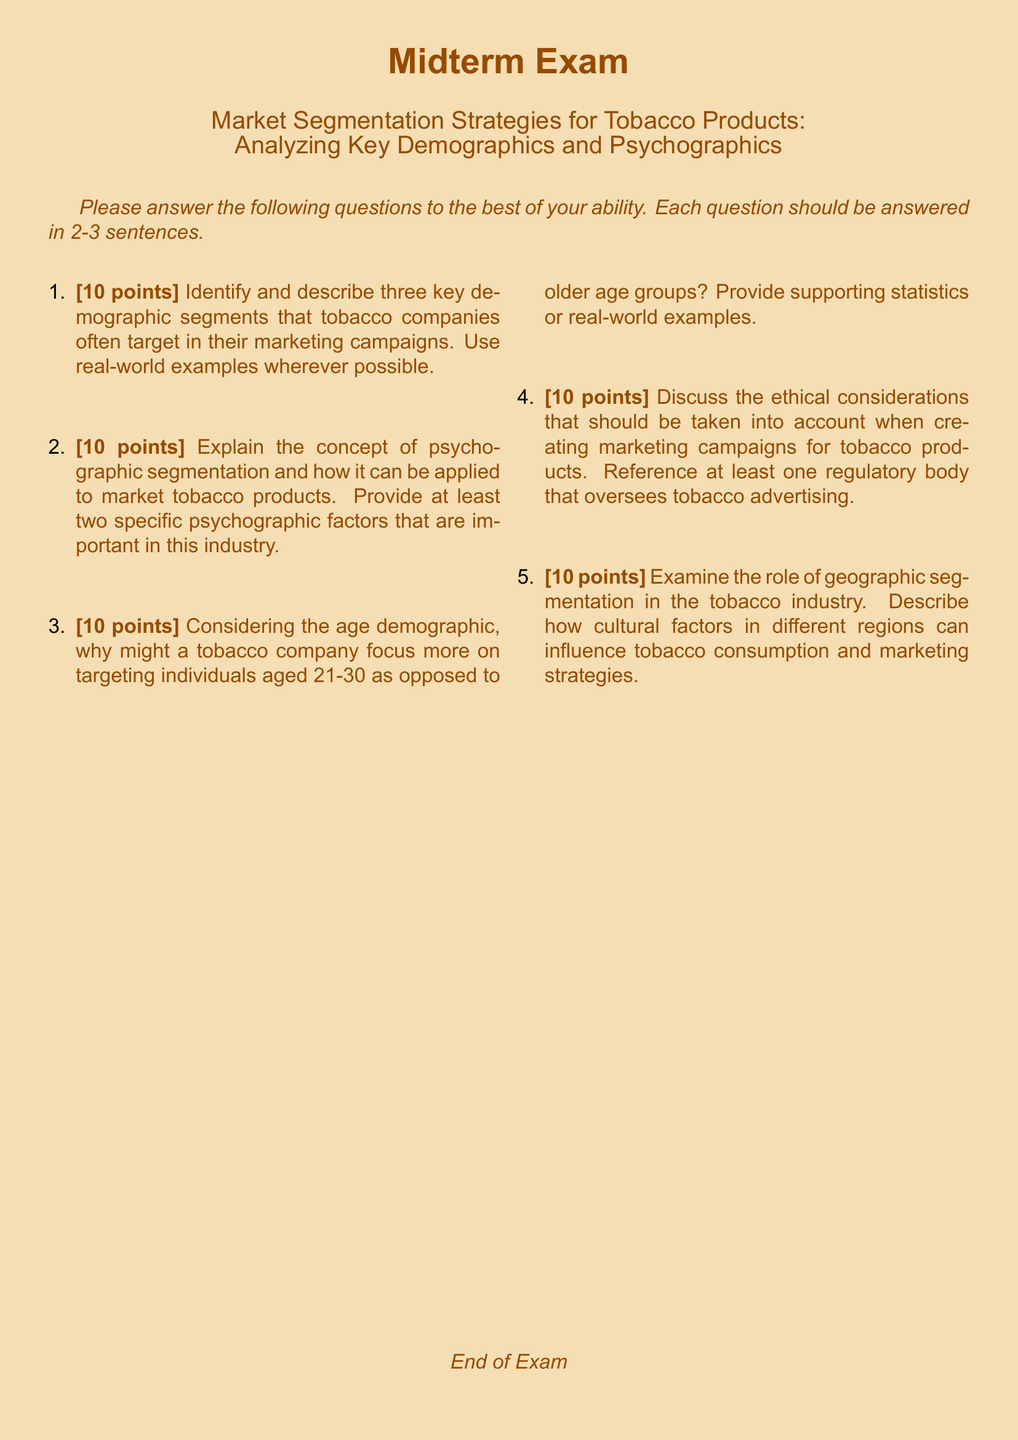What is the title of the document? The title is explicitly stated at the beginning of the document as "Market Segmentation Strategies for Tobacco Products: Analyzing Key Demographics and Psychographics."
Answer: Market Segmentation Strategies for Tobacco Products: Analyzing Key Demographics and Psychographics How many questions are included in the midterm exam? There are a total of five questions listed in the exam document.
Answer: 5 What is the maximum number of points for each question? Each question is worth a maximum of 10 points, as indicated in the document.
Answer: 10 points What kind of segmentation is discussed as a method for marketing tobacco products? The document mentions psychographic segmentation as a method that can be applied to market tobacco products.
Answer: Psychographic segmentation What age demographic is specifically mentioned for targeting in tobacco marketing? The document focuses on individuals aged 21-30 in relation to targeting in tobacco marketing.
Answer: 21-30 Which regulatory body is referenced in the context of tobacco advertising ethics? The document mentions a regulatory body but does not specify which one; however, a common reference would be the FDA.
Answer: FDA What color is used for the document’s main title? The main title is colored in a brown shade defined as Tobaccobrown in the document.
Answer: Tobaccobrown What should each answer be limited to according to the exam instructions? Each answer should be limited to 2-3 sentences as per the instructions in the document.
Answer: 2-3 sentences What cultural aspect does the document suggest influences tobacco marketing? The document suggests that cultural factors in different regions can influence tobacco consumption and marketing strategies.
Answer: Cultural factors 